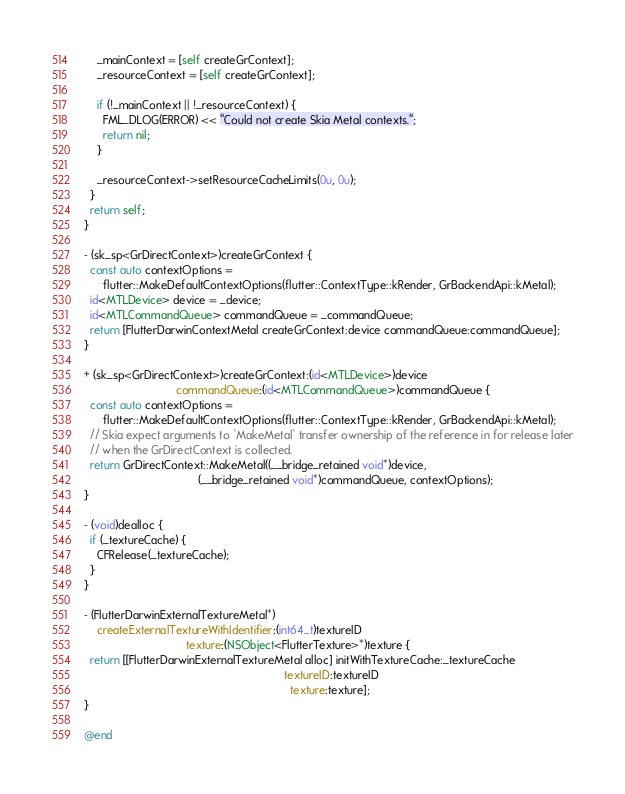Convert code to text. <code><loc_0><loc_0><loc_500><loc_500><_ObjectiveC_>    _mainContext = [self createGrContext];
    _resourceContext = [self createGrContext];

    if (!_mainContext || !_resourceContext) {
      FML_DLOG(ERROR) << "Could not create Skia Metal contexts.";
      return nil;
    }

    _resourceContext->setResourceCacheLimits(0u, 0u);
  }
  return self;
}

- (sk_sp<GrDirectContext>)createGrContext {
  const auto contextOptions =
      flutter::MakeDefaultContextOptions(flutter::ContextType::kRender, GrBackendApi::kMetal);
  id<MTLDevice> device = _device;
  id<MTLCommandQueue> commandQueue = _commandQueue;
  return [FlutterDarwinContextMetal createGrContext:device commandQueue:commandQueue];
}

+ (sk_sp<GrDirectContext>)createGrContext:(id<MTLDevice>)device
                             commandQueue:(id<MTLCommandQueue>)commandQueue {
  const auto contextOptions =
      flutter::MakeDefaultContextOptions(flutter::ContextType::kRender, GrBackendApi::kMetal);
  // Skia expect arguments to `MakeMetal` transfer ownership of the reference in for release later
  // when the GrDirectContext is collected.
  return GrDirectContext::MakeMetal((__bridge_retained void*)device,
                                    (__bridge_retained void*)commandQueue, contextOptions);
}

- (void)dealloc {
  if (_textureCache) {
    CFRelease(_textureCache);
  }
}

- (FlutterDarwinExternalTextureMetal*)
    createExternalTextureWithIdentifier:(int64_t)textureID
                                texture:(NSObject<FlutterTexture>*)texture {
  return [[FlutterDarwinExternalTextureMetal alloc] initWithTextureCache:_textureCache
                                                               textureID:textureID
                                                                 texture:texture];
}

@end
</code> 